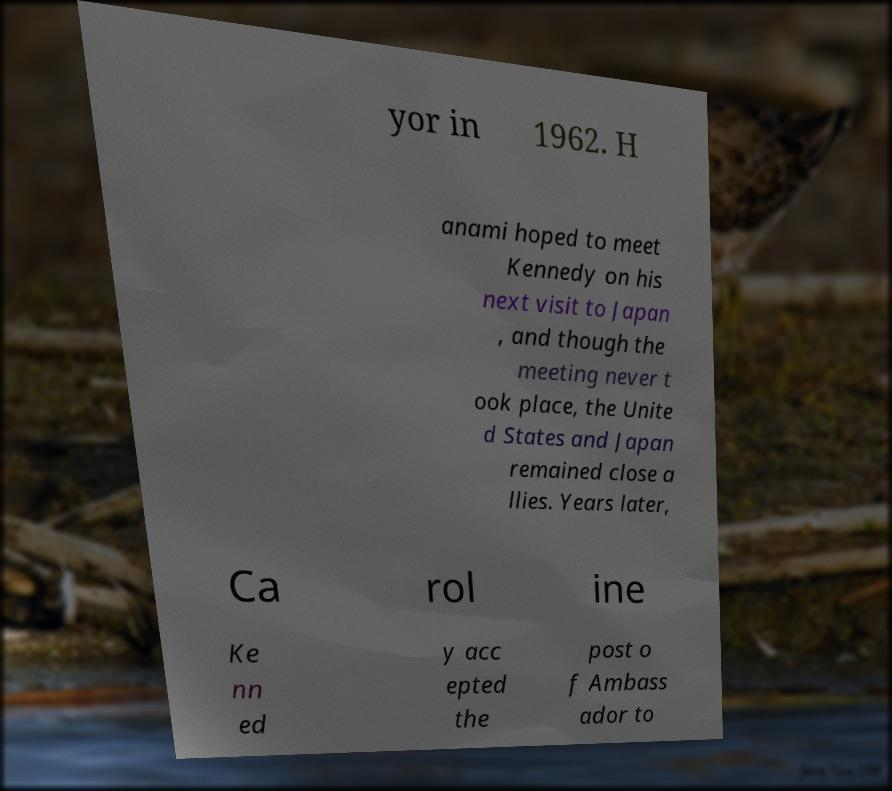Can you read and provide the text displayed in the image?This photo seems to have some interesting text. Can you extract and type it out for me? yor in 1962. H anami hoped to meet Kennedy on his next visit to Japan , and though the meeting never t ook place, the Unite d States and Japan remained close a llies. Years later, Ca rol ine Ke nn ed y acc epted the post o f Ambass ador to 